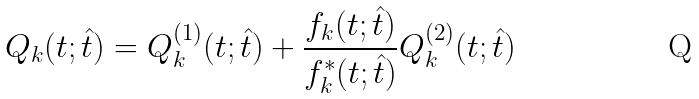Convert formula to latex. <formula><loc_0><loc_0><loc_500><loc_500>Q _ { k } ( t ; \hat { t } ) = Q _ { k } ^ { ( 1 ) } ( t ; \hat { t } ) + \frac { f _ { k } ( t ; \hat { t } ) } { f _ { k } ^ { * } ( t ; \hat { t } ) } Q _ { k } ^ { ( 2 ) } ( t ; \hat { t } )</formula> 